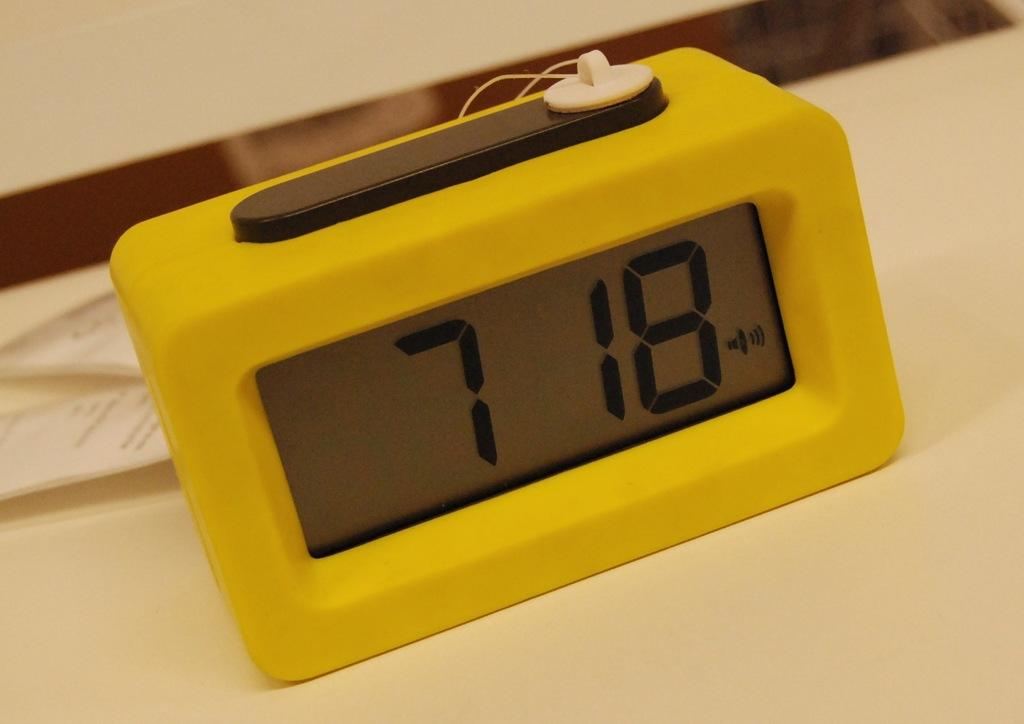<image>
Render a clear and concise summary of the photo. a digital clock with the  time at 7 18 